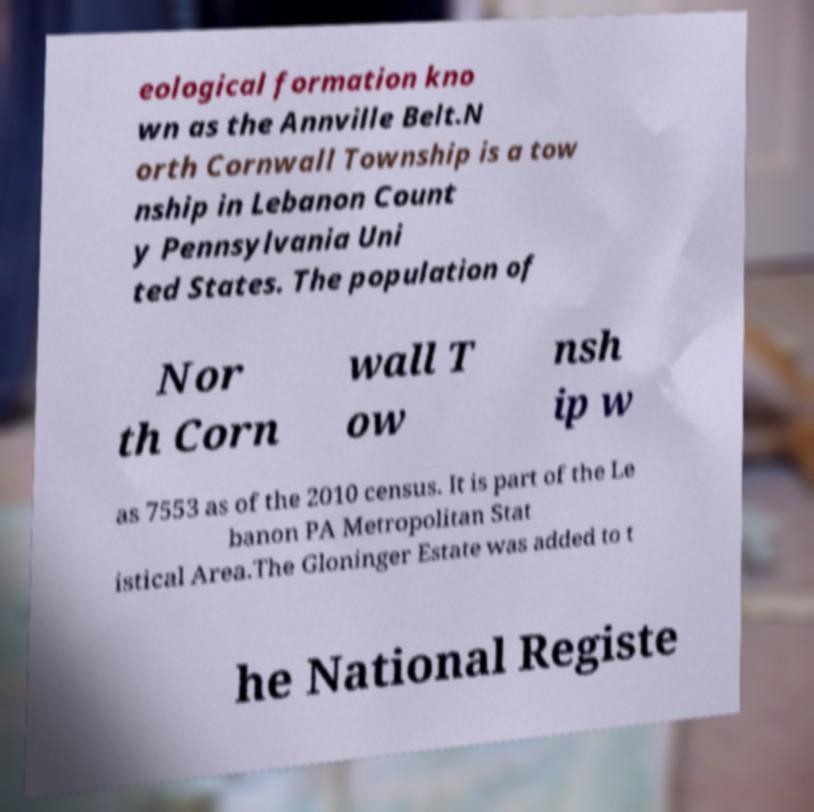For documentation purposes, I need the text within this image transcribed. Could you provide that? eological formation kno wn as the Annville Belt.N orth Cornwall Township is a tow nship in Lebanon Count y Pennsylvania Uni ted States. The population of Nor th Corn wall T ow nsh ip w as 7553 as of the 2010 census. It is part of the Le banon PA Metropolitan Stat istical Area.The Gloninger Estate was added to t he National Registe 